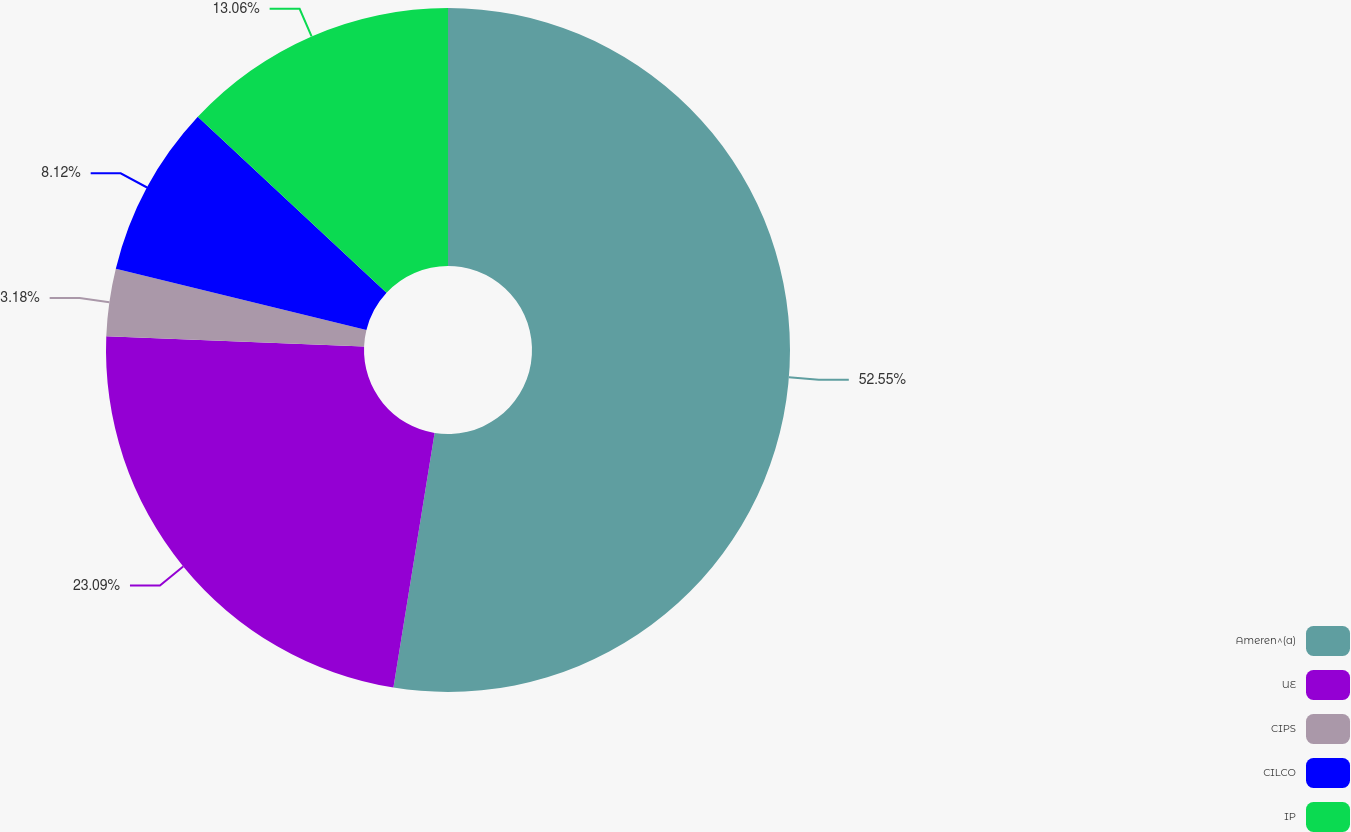Convert chart to OTSL. <chart><loc_0><loc_0><loc_500><loc_500><pie_chart><fcel>Ameren^(a)<fcel>UE<fcel>CIPS<fcel>CILCO<fcel>IP<nl><fcel>52.55%<fcel>23.09%<fcel>3.18%<fcel>8.12%<fcel>13.06%<nl></chart> 